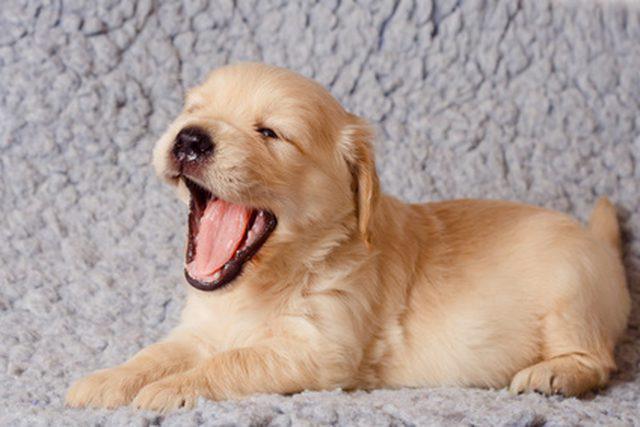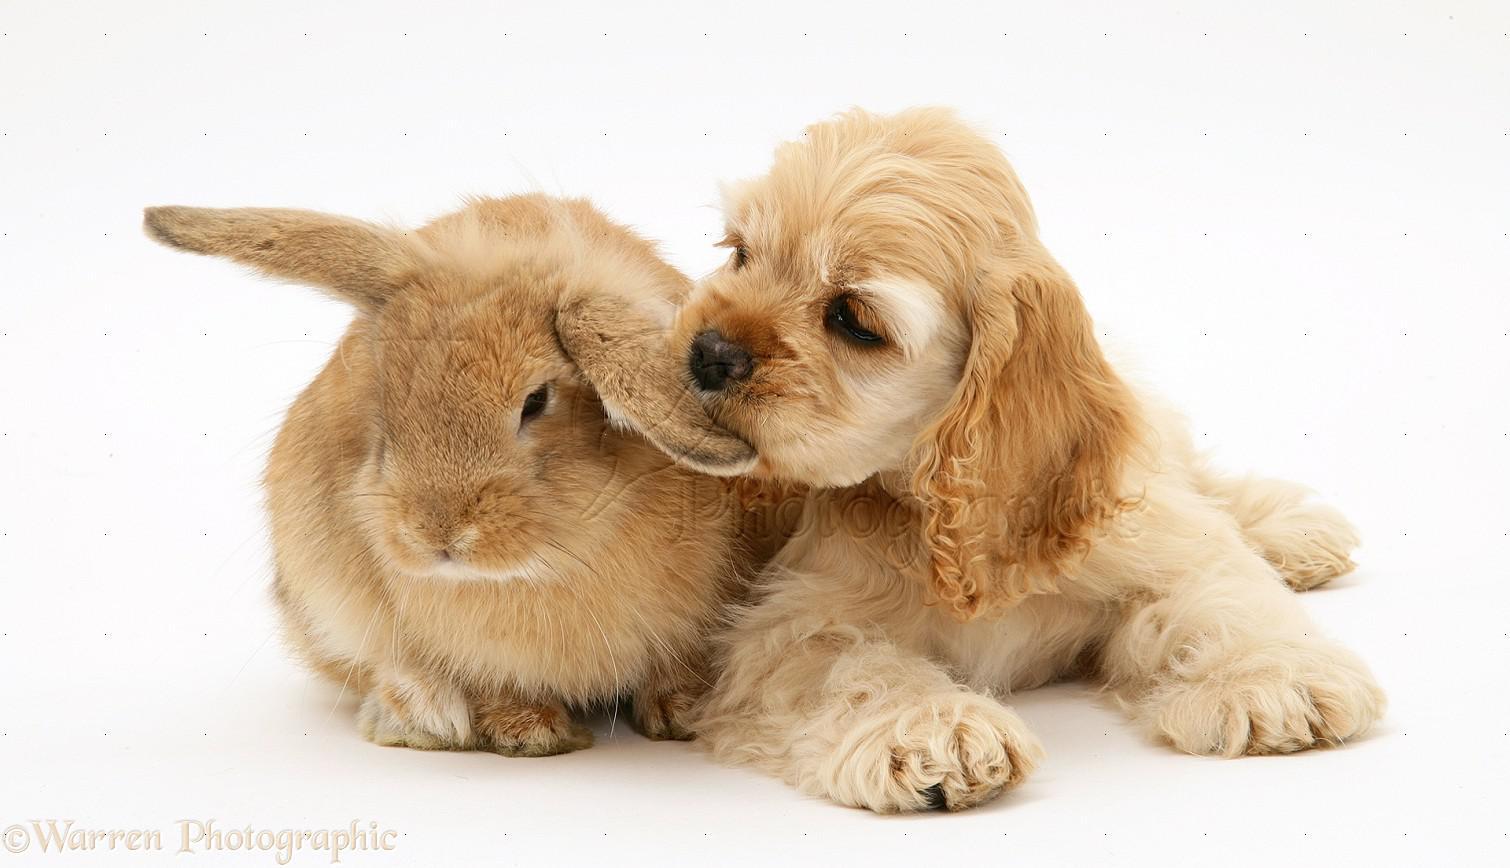The first image is the image on the left, the second image is the image on the right. Examine the images to the left and right. Is the description "There is a young tan puppy on top of a curlyhaired brown puppy." accurate? Answer yes or no. No. The first image is the image on the left, the second image is the image on the right. For the images shown, is this caption "There are two dogs in the left image." true? Answer yes or no. No. 